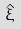Convert formula to latex. <formula><loc_0><loc_0><loc_500><loc_500>\hat { \xi }</formula> 